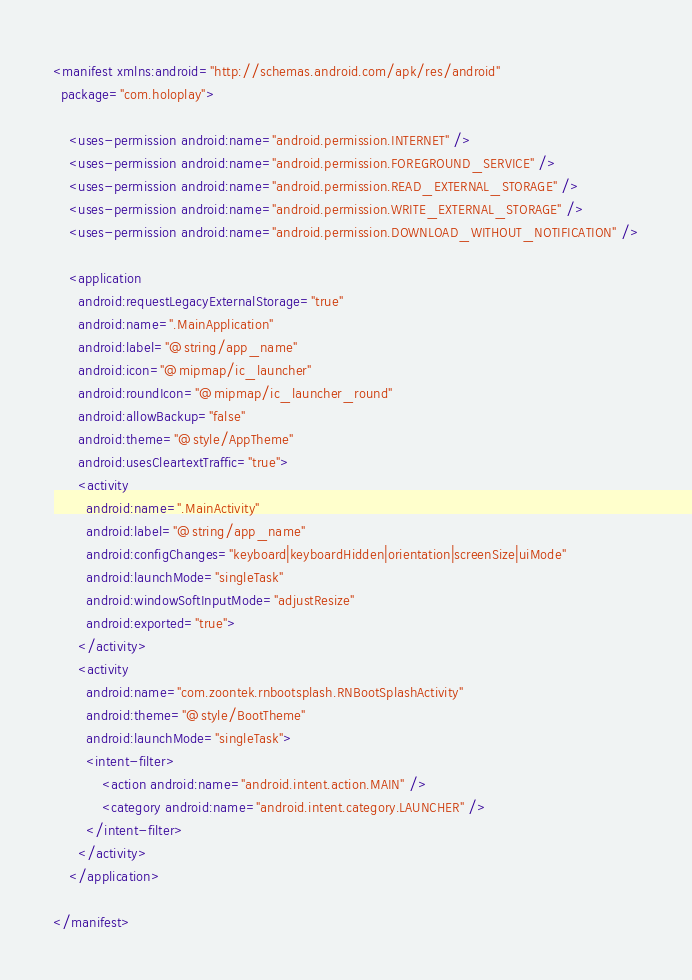<code> <loc_0><loc_0><loc_500><loc_500><_XML_><manifest xmlns:android="http://schemas.android.com/apk/res/android"
  package="com.holoplay">

    <uses-permission android:name="android.permission.INTERNET" />
    <uses-permission android:name="android.permission.FOREGROUND_SERVICE" />
    <uses-permission android:name="android.permission.READ_EXTERNAL_STORAGE" />
    <uses-permission android:name="android.permission.WRITE_EXTERNAL_STORAGE" />
    <uses-permission android:name="android.permission.DOWNLOAD_WITHOUT_NOTIFICATION" />

    <application
      android:requestLegacyExternalStorage="true"
      android:name=".MainApplication"
      android:label="@string/app_name"
      android:icon="@mipmap/ic_launcher"
      android:roundIcon="@mipmap/ic_launcher_round"
      android:allowBackup="false"
      android:theme="@style/AppTheme"
      android:usesCleartextTraffic="true">
      <activity
        android:name=".MainActivity"
        android:label="@string/app_name"
        android:configChanges="keyboard|keyboardHidden|orientation|screenSize|uiMode"
        android:launchMode="singleTask"
        android:windowSoftInputMode="adjustResize"
        android:exported="true">
      </activity>
      <activity
        android:name="com.zoontek.rnbootsplash.RNBootSplashActivity"
        android:theme="@style/BootTheme"
        android:launchMode="singleTask">
        <intent-filter>
            <action android:name="android.intent.action.MAIN" />
            <category android:name="android.intent.category.LAUNCHER" />
        </intent-filter>
      </activity>
    </application>

</manifest>
</code> 